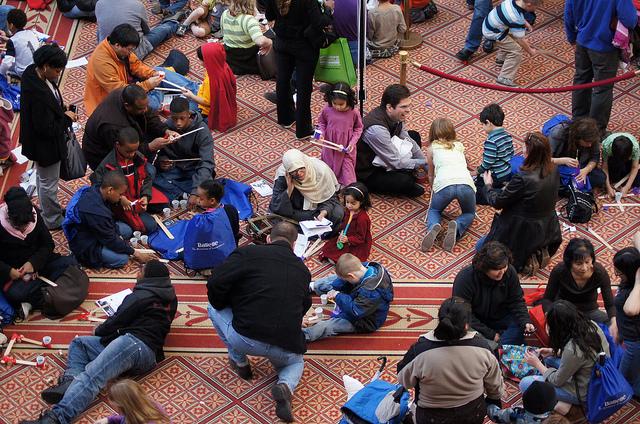Are all of the people adults?
Write a very short answer. No. What is the orange object on the left of this picture?
Give a very brief answer. Jacket. What are the people sitting on?
Write a very short answer. Floor. Are there many children in the picture?
Answer briefly. Yes. 